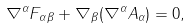Convert formula to latex. <formula><loc_0><loc_0><loc_500><loc_500>\nabla ^ { \alpha } F _ { \alpha \beta } + \nabla _ { \beta } ( \nabla ^ { \alpha } A _ { \alpha } ) = 0 ,</formula> 